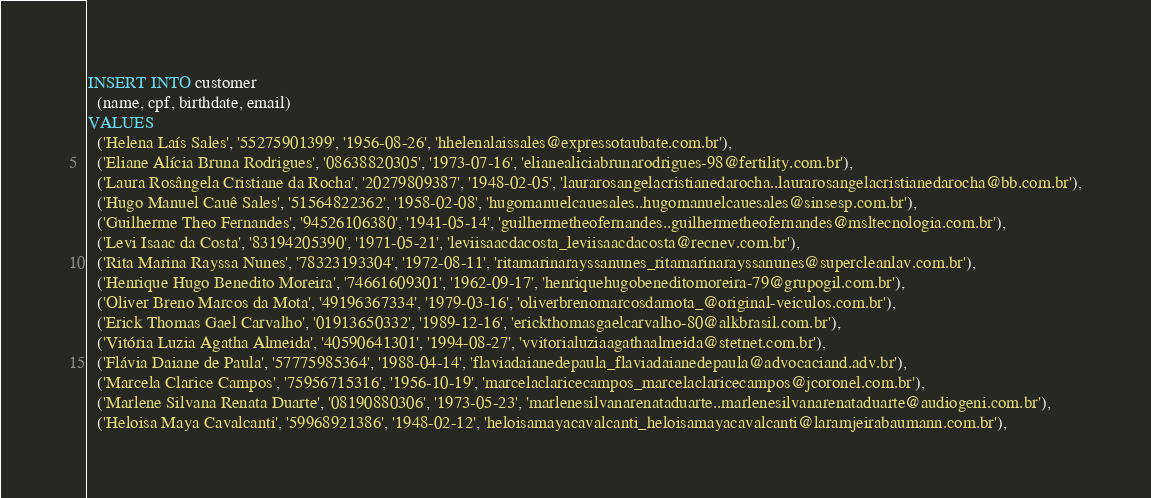<code> <loc_0><loc_0><loc_500><loc_500><_SQL_>INSERT INTO customer
  (name, cpf, birthdate, email)
VALUES
  ('Helena Laís Sales', '55275901399', '1956-08-26', 'hhelenalaissales@expressotaubate.com.br'),
  ('Eliane Alícia Bruna Rodrigues', '08638820305', '1973-07-16', 'elianealiciabrunarodrigues-98@fertility.com.br'),
  ('Laura Rosângela Cristiane da Rocha', '20279809387', '1948-02-05', 'laurarosangelacristianedarocha..laurarosangelacristianedarocha@bb.com.br'),
  ('Hugo Manuel Cauê Sales', '51564822362', '1958-02-08', 'hugomanuelcauesales..hugomanuelcauesales@sinsesp.com.br'),
  ('Guilherme Theo Fernandes', '94526106380', '1941-05-14', 'guilhermetheofernandes..guilhermetheofernandes@msltecnologia.com.br'),
  ('Levi Isaac da Costa', '83194205390', '1971-05-21', 'leviisaacdacosta_leviisaacdacosta@recnev.com.br'),
  ('Rita Marina Rayssa Nunes', '78323193304', '1972-08-11', 'ritamarinarayssanunes_ritamarinarayssanunes@supercleanlav.com.br'),
  ('Henrique Hugo Benedito Moreira', '74661609301', '1962-09-17', 'henriquehugobeneditomoreira-79@grupogil.com.br'),
  ('Oliver Breno Marcos da Mota', '49196367334', '1979-03-16', 'oliverbrenomarcosdamota_@original-veiculos.com.br'),
  ('Erick Thomas Gael Carvalho', '01913650332', '1989-12-16', 'erickthomasgaelcarvalho-80@alkbrasil.com.br'),
  ('Vitória Luzia Agatha Almeida', '40590641301', '1994-08-27', 'vvitorialuziaagathaalmeida@stetnet.com.br'),
  ('Flávia Daiane de Paula', '57775985364', '1988-04-14', 'flaviadaianedepaula_flaviadaianedepaula@advocaciand.adv.br'),
  ('Marcela Clarice Campos', '75956715316', '1956-10-19', 'marcelaclaricecampos_marcelaclaricecampos@jcoronel.com.br'),
  ('Marlene Silvana Renata Duarte', '08190880306', '1973-05-23', 'marlenesilvanarenataduarte..marlenesilvanarenataduarte@audiogeni.com.br'),
  ('Heloisa Maya Cavalcanti', '59968921386', '1948-02-12', 'heloisamayacavalcanti_heloisamayacavalcanti@laramjeirabaumann.com.br'),</code> 